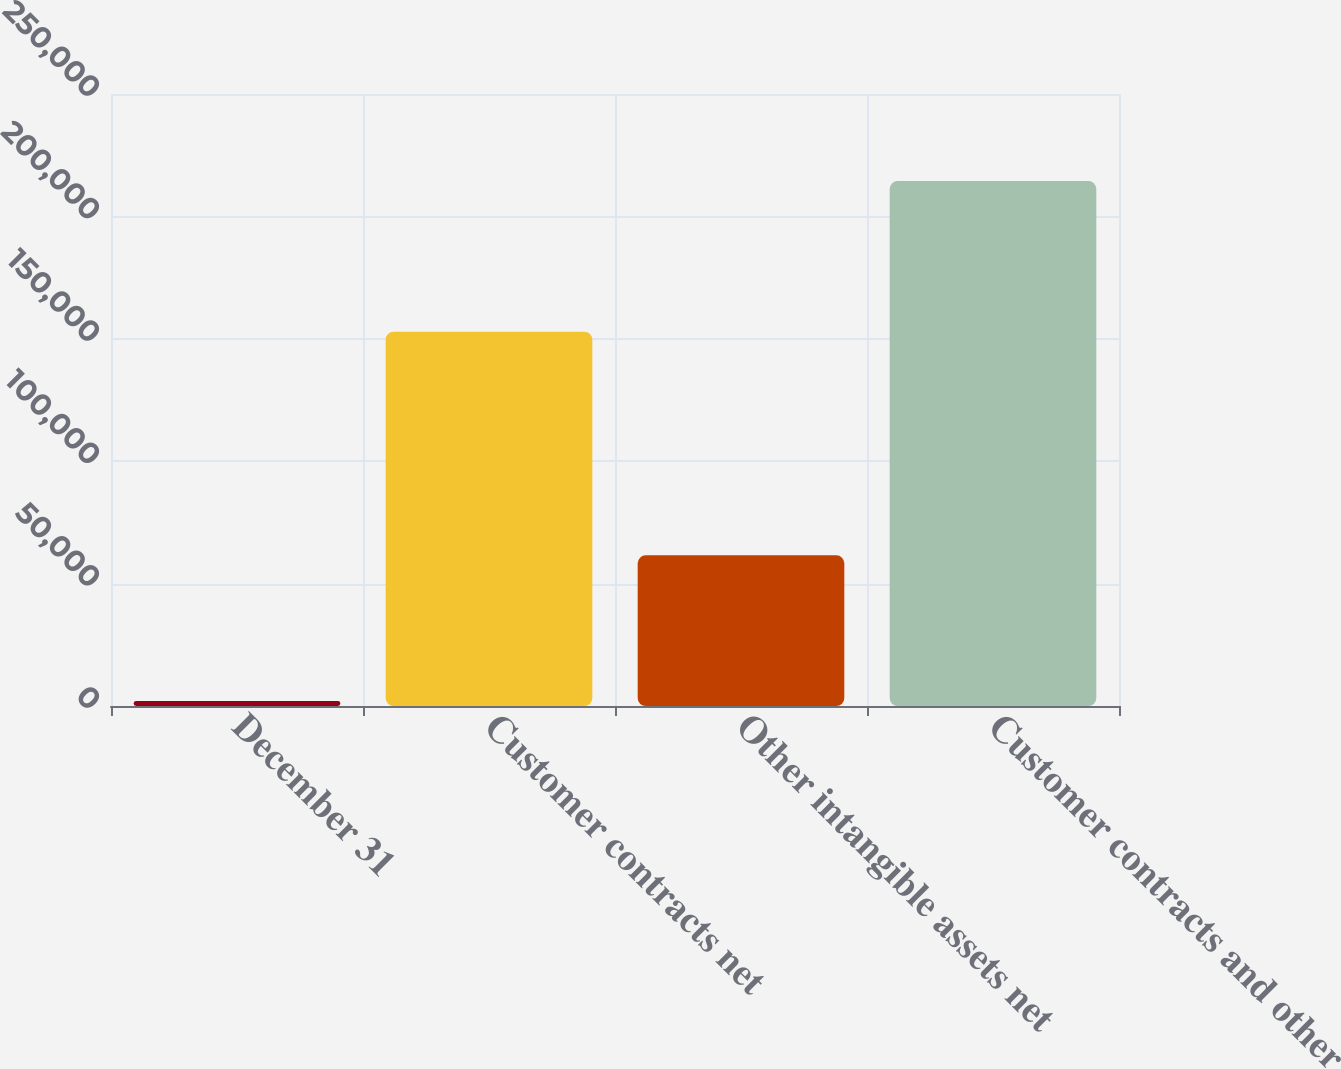Convert chart to OTSL. <chart><loc_0><loc_0><loc_500><loc_500><bar_chart><fcel>December 31<fcel>Customer contracts net<fcel>Other intangible assets net<fcel>Customer contracts and other<nl><fcel>2017<fcel>152869<fcel>61548<fcel>214417<nl></chart> 